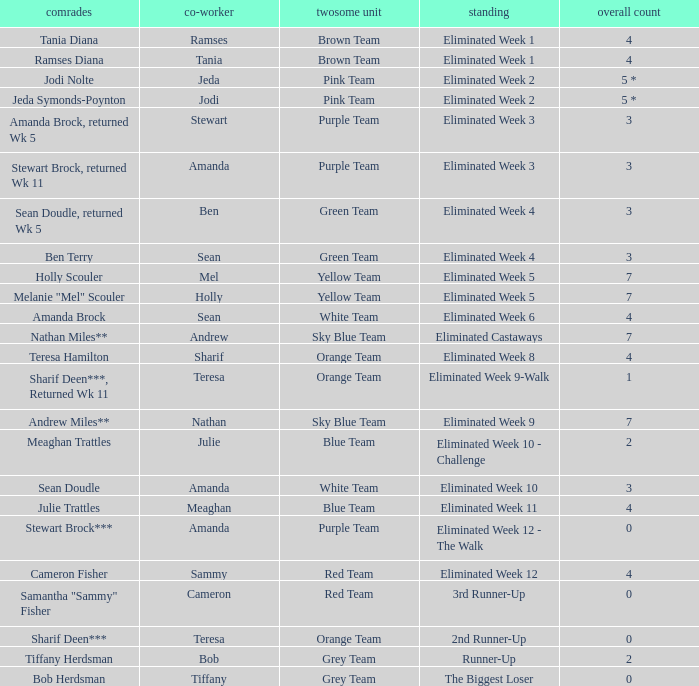What were Holly Scouler's total votes? 7.0. 